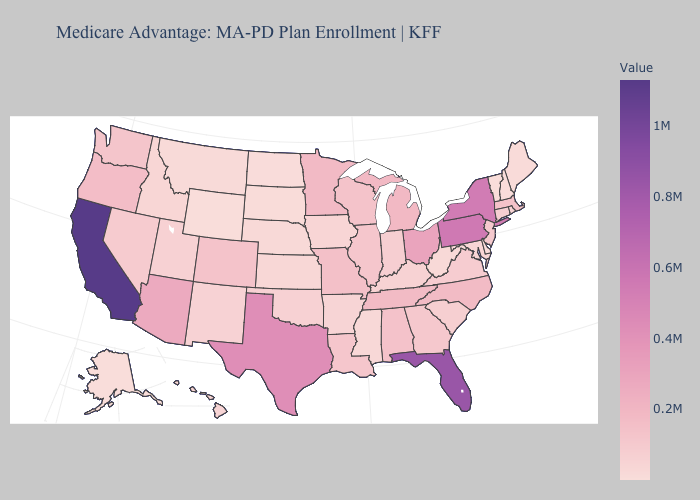Among the states that border Utah , which have the highest value?
Keep it brief. Arizona. Among the states that border Virginia , which have the highest value?
Short answer required. Tennessee. Does the map have missing data?
Write a very short answer. No. Does Arizona have the lowest value in the USA?
Concise answer only. No. Among the states that border Kansas , which have the lowest value?
Short answer required. Nebraska. Does Delaware have the lowest value in the South?
Short answer required. Yes. Does Michigan have a lower value than Texas?
Give a very brief answer. Yes. 